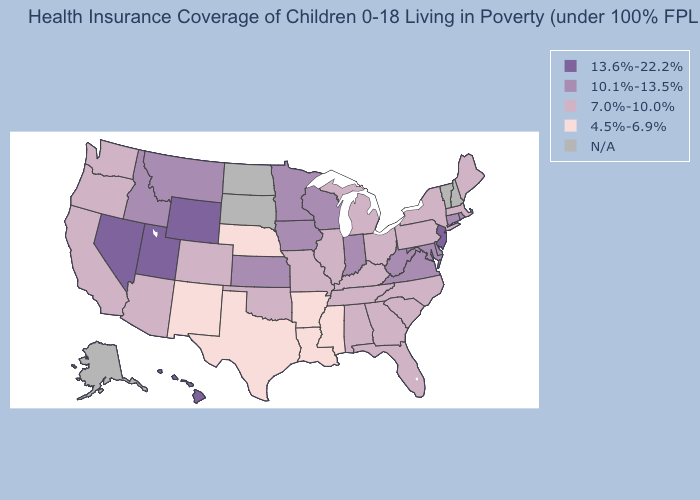Name the states that have a value in the range N/A?
Answer briefly. Alaska, New Hampshire, North Dakota, South Dakota, Vermont. Does the map have missing data?
Keep it brief. Yes. What is the value of Tennessee?
Give a very brief answer. 7.0%-10.0%. What is the value of Minnesota?
Answer briefly. 10.1%-13.5%. Name the states that have a value in the range 4.5%-6.9%?
Short answer required. Arkansas, Louisiana, Mississippi, Nebraska, New Mexico, Texas. Name the states that have a value in the range 7.0%-10.0%?
Short answer required. Alabama, Arizona, California, Colorado, Florida, Georgia, Illinois, Kentucky, Maine, Massachusetts, Michigan, Missouri, New York, North Carolina, Ohio, Oklahoma, Oregon, Pennsylvania, South Carolina, Tennessee, Washington. Name the states that have a value in the range 13.6%-22.2%?
Give a very brief answer. Hawaii, Nevada, New Jersey, Utah, Wyoming. Among the states that border New York , which have the lowest value?
Write a very short answer. Massachusetts, Pennsylvania. What is the value of Vermont?
Keep it brief. N/A. What is the value of Alaska?
Short answer required. N/A. How many symbols are there in the legend?
Be succinct. 5. Does the map have missing data?
Keep it brief. Yes. Which states hav the highest value in the West?
Short answer required. Hawaii, Nevada, Utah, Wyoming. Does Washington have the highest value in the USA?
Keep it brief. No. 